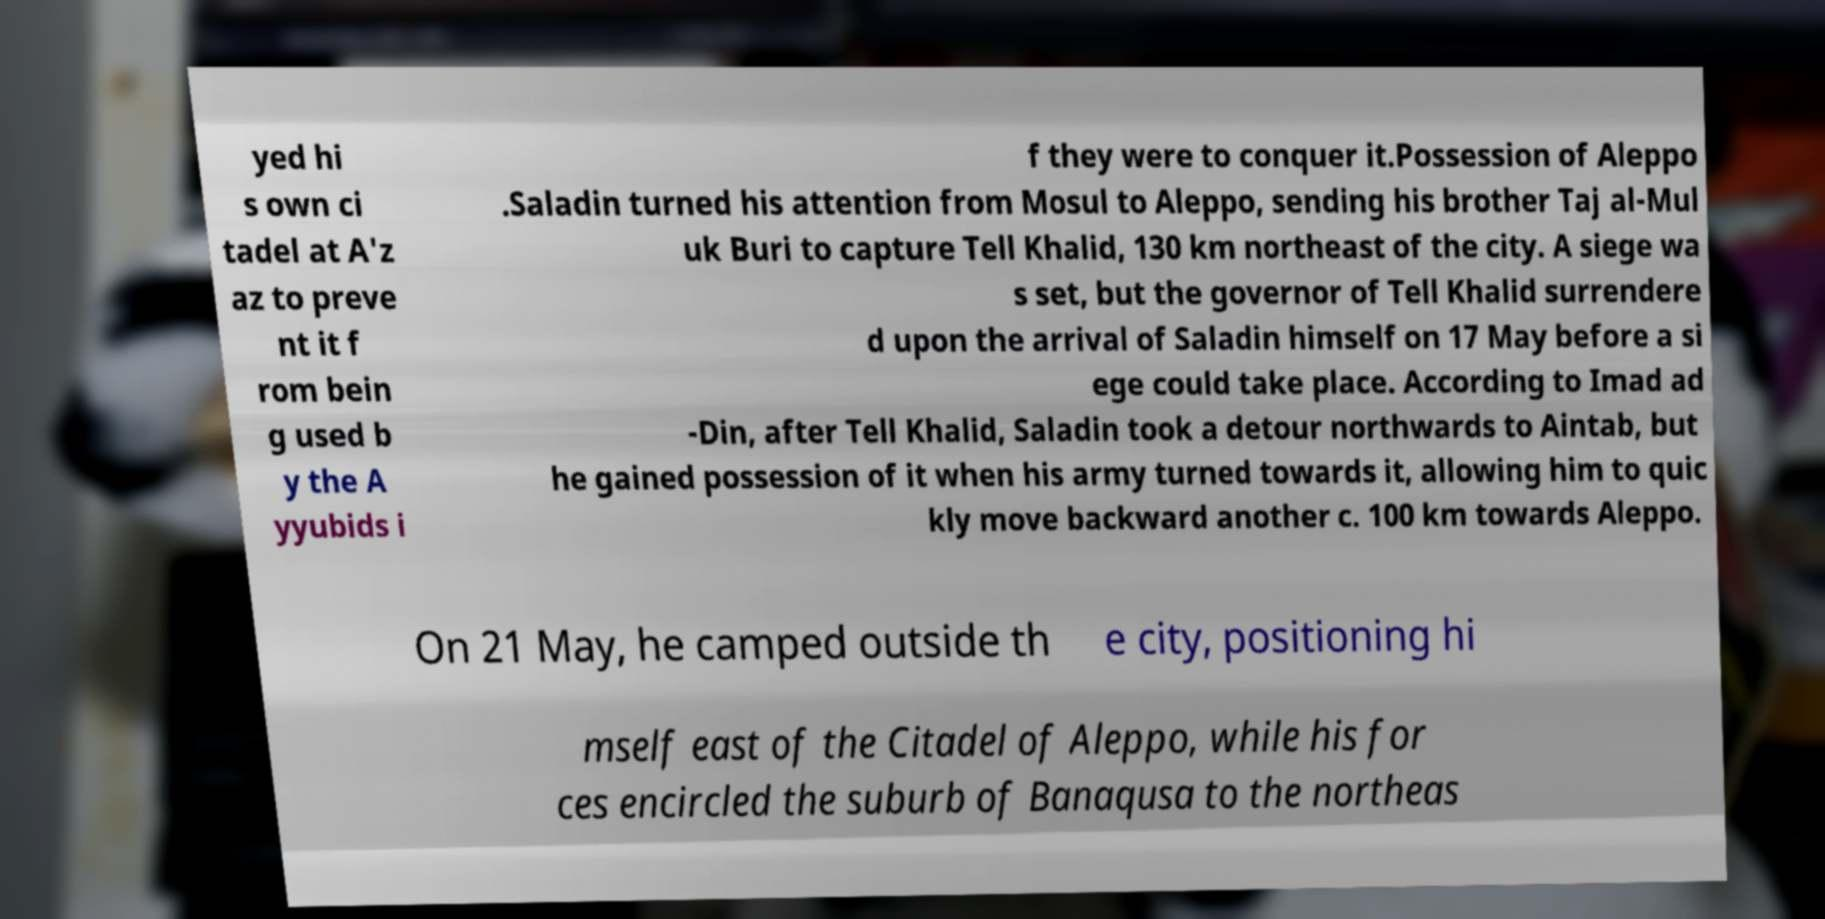What messages or text are displayed in this image? I need them in a readable, typed format. yed hi s own ci tadel at A'z az to preve nt it f rom bein g used b y the A yyubids i f they were to conquer it.Possession of Aleppo .Saladin turned his attention from Mosul to Aleppo, sending his brother Taj al-Mul uk Buri to capture Tell Khalid, 130 km northeast of the city. A siege wa s set, but the governor of Tell Khalid surrendere d upon the arrival of Saladin himself on 17 May before a si ege could take place. According to Imad ad -Din, after Tell Khalid, Saladin took a detour northwards to Aintab, but he gained possession of it when his army turned towards it, allowing him to quic kly move backward another c. 100 km towards Aleppo. On 21 May, he camped outside th e city, positioning hi mself east of the Citadel of Aleppo, while his for ces encircled the suburb of Banaqusa to the northeas 